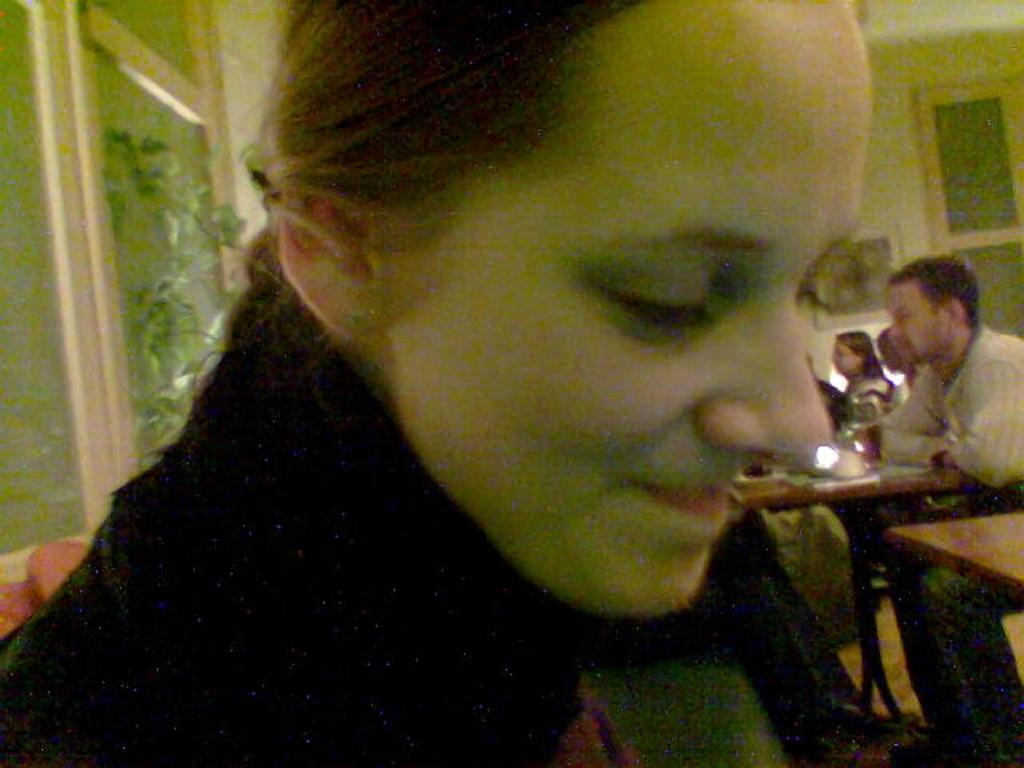Please provide a concise description of this image. In front of the image there is a person. Behind her there are people sitting on the chairs. There are tables. On the left side of the image there are pillows on the sofa. There is a plant. There are glass windows. In the background of the image there are photo frames on the wall. 